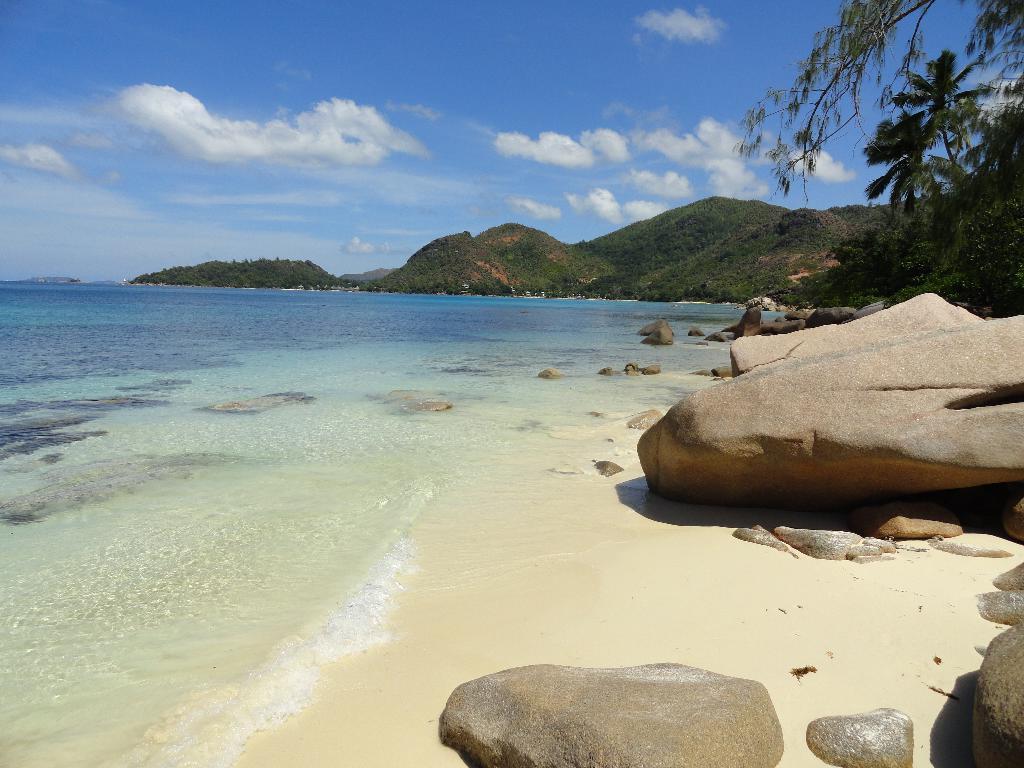Could you give a brief overview of what you see in this image? We can see water,trees and stones. On the background we can see hill and sky with clouds. 